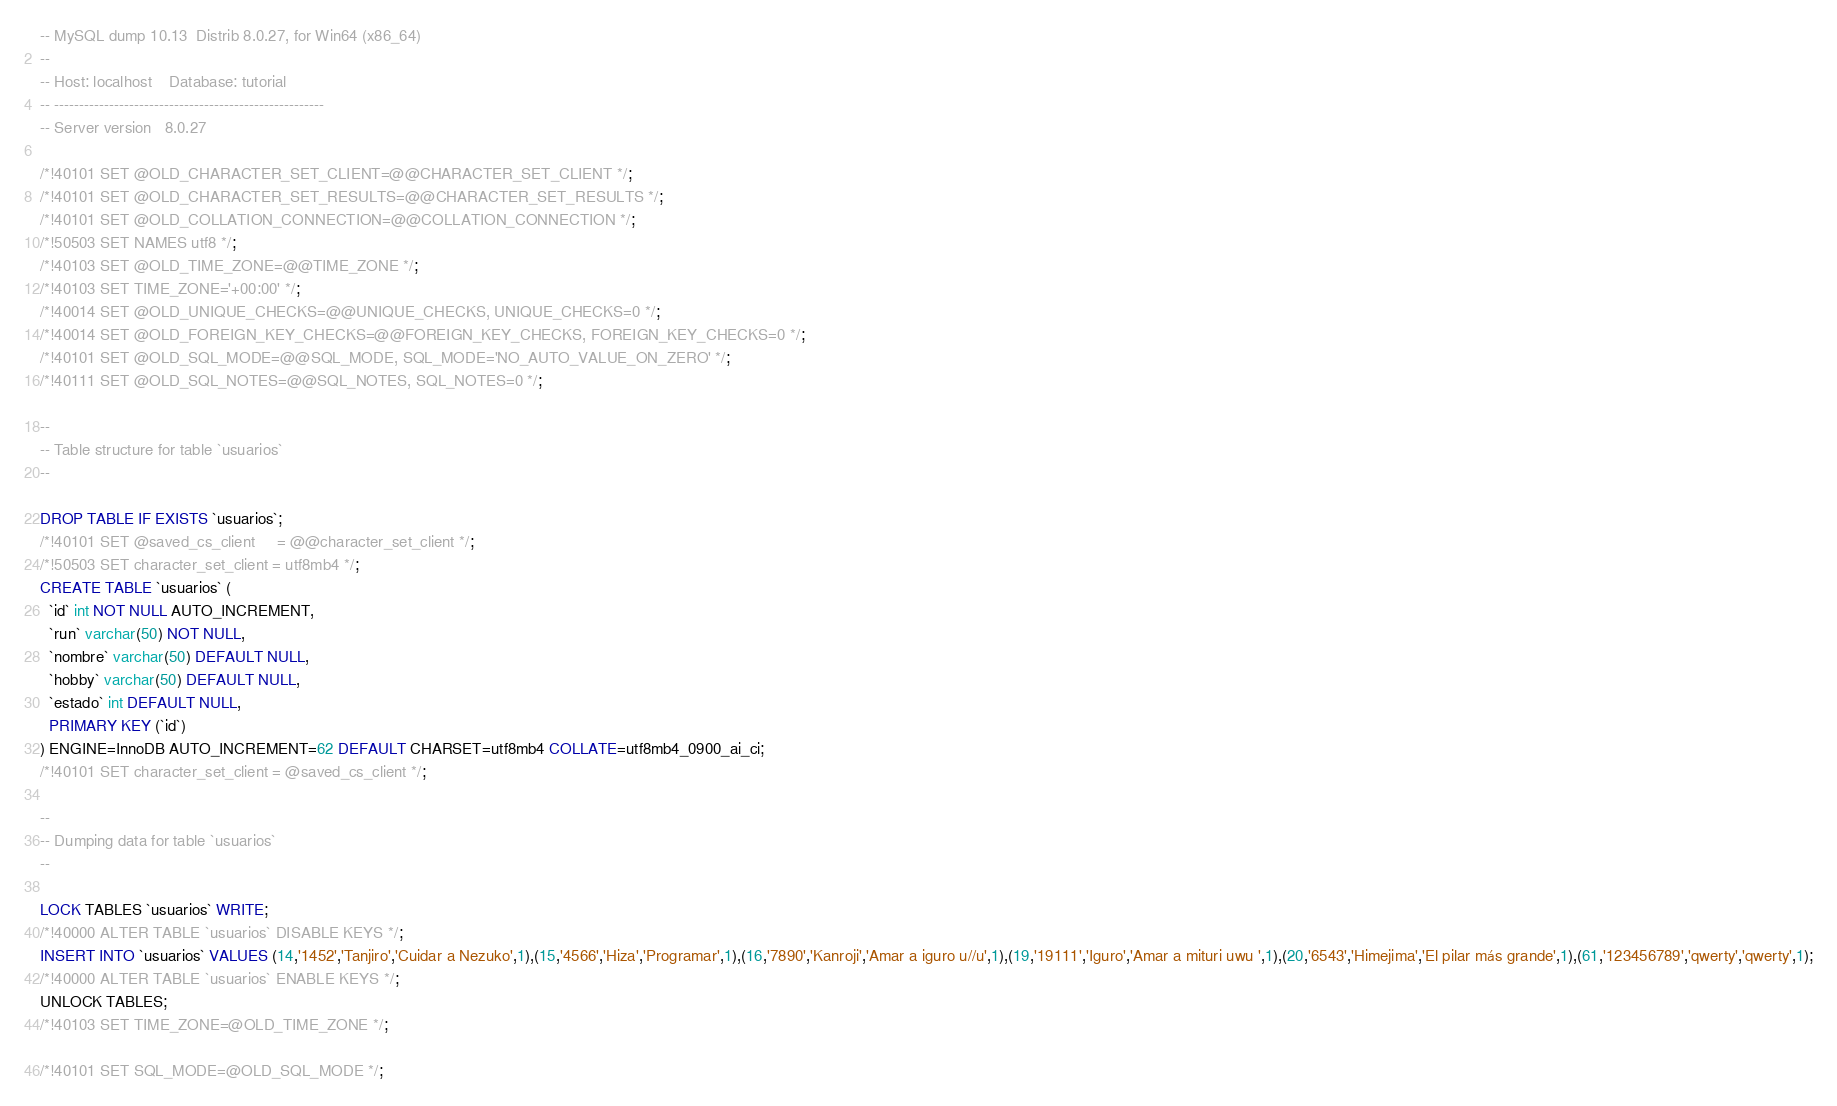<code> <loc_0><loc_0><loc_500><loc_500><_SQL_>-- MySQL dump 10.13  Distrib 8.0.27, for Win64 (x86_64)
--
-- Host: localhost    Database: tutorial
-- ------------------------------------------------------
-- Server version	8.0.27

/*!40101 SET @OLD_CHARACTER_SET_CLIENT=@@CHARACTER_SET_CLIENT */;
/*!40101 SET @OLD_CHARACTER_SET_RESULTS=@@CHARACTER_SET_RESULTS */;
/*!40101 SET @OLD_COLLATION_CONNECTION=@@COLLATION_CONNECTION */;
/*!50503 SET NAMES utf8 */;
/*!40103 SET @OLD_TIME_ZONE=@@TIME_ZONE */;
/*!40103 SET TIME_ZONE='+00:00' */;
/*!40014 SET @OLD_UNIQUE_CHECKS=@@UNIQUE_CHECKS, UNIQUE_CHECKS=0 */;
/*!40014 SET @OLD_FOREIGN_KEY_CHECKS=@@FOREIGN_KEY_CHECKS, FOREIGN_KEY_CHECKS=0 */;
/*!40101 SET @OLD_SQL_MODE=@@SQL_MODE, SQL_MODE='NO_AUTO_VALUE_ON_ZERO' */;
/*!40111 SET @OLD_SQL_NOTES=@@SQL_NOTES, SQL_NOTES=0 */;

--
-- Table structure for table `usuarios`
--

DROP TABLE IF EXISTS `usuarios`;
/*!40101 SET @saved_cs_client     = @@character_set_client */;
/*!50503 SET character_set_client = utf8mb4 */;
CREATE TABLE `usuarios` (
  `id` int NOT NULL AUTO_INCREMENT,
  `run` varchar(50) NOT NULL,
  `nombre` varchar(50) DEFAULT NULL,
  `hobby` varchar(50) DEFAULT NULL,
  `estado` int DEFAULT NULL,
  PRIMARY KEY (`id`)
) ENGINE=InnoDB AUTO_INCREMENT=62 DEFAULT CHARSET=utf8mb4 COLLATE=utf8mb4_0900_ai_ci;
/*!40101 SET character_set_client = @saved_cs_client */;

--
-- Dumping data for table `usuarios`
--

LOCK TABLES `usuarios` WRITE;
/*!40000 ALTER TABLE `usuarios` DISABLE KEYS */;
INSERT INTO `usuarios` VALUES (14,'1452','Tanjiro','Cuidar a Nezuko',1),(15,'4566','Hiza','Programar',1),(16,'7890','Kanroji','Amar a iguro u//u',1),(19,'19111','Iguro','Amar a mituri uwu ',1),(20,'6543','Himejima','El pilar más grande',1),(61,'123456789','qwerty','qwerty',1);
/*!40000 ALTER TABLE `usuarios` ENABLE KEYS */;
UNLOCK TABLES;
/*!40103 SET TIME_ZONE=@OLD_TIME_ZONE */;

/*!40101 SET SQL_MODE=@OLD_SQL_MODE */;</code> 